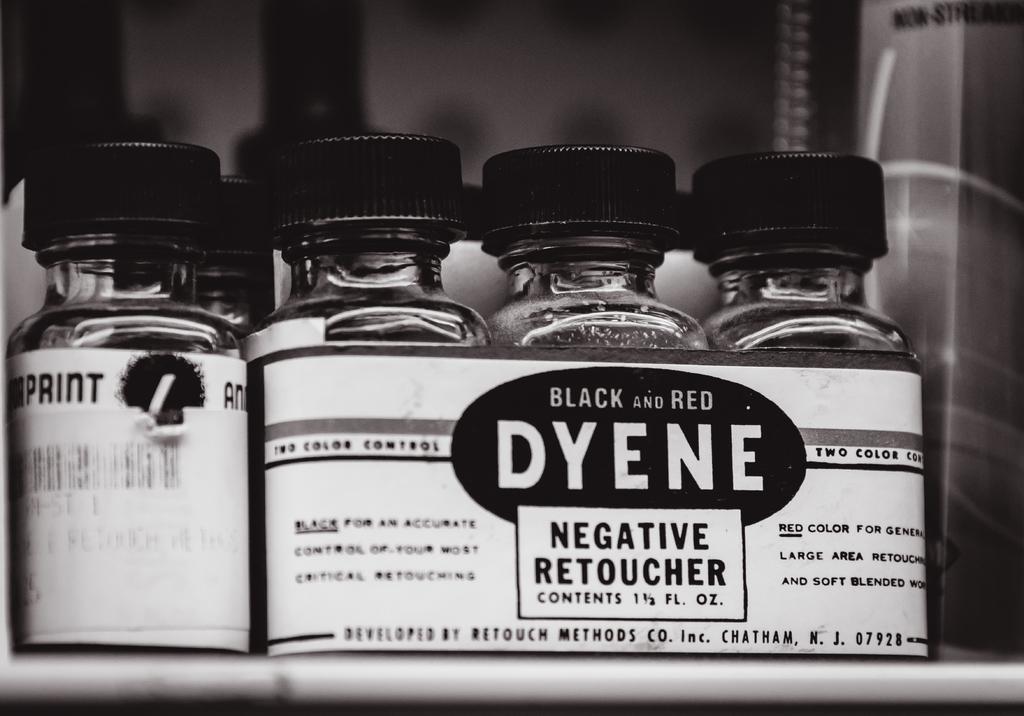What colours are the bottles?
Make the answer very short. Black and red. What is the brand for this negative retoucher?
Provide a succinct answer. Dyene. 